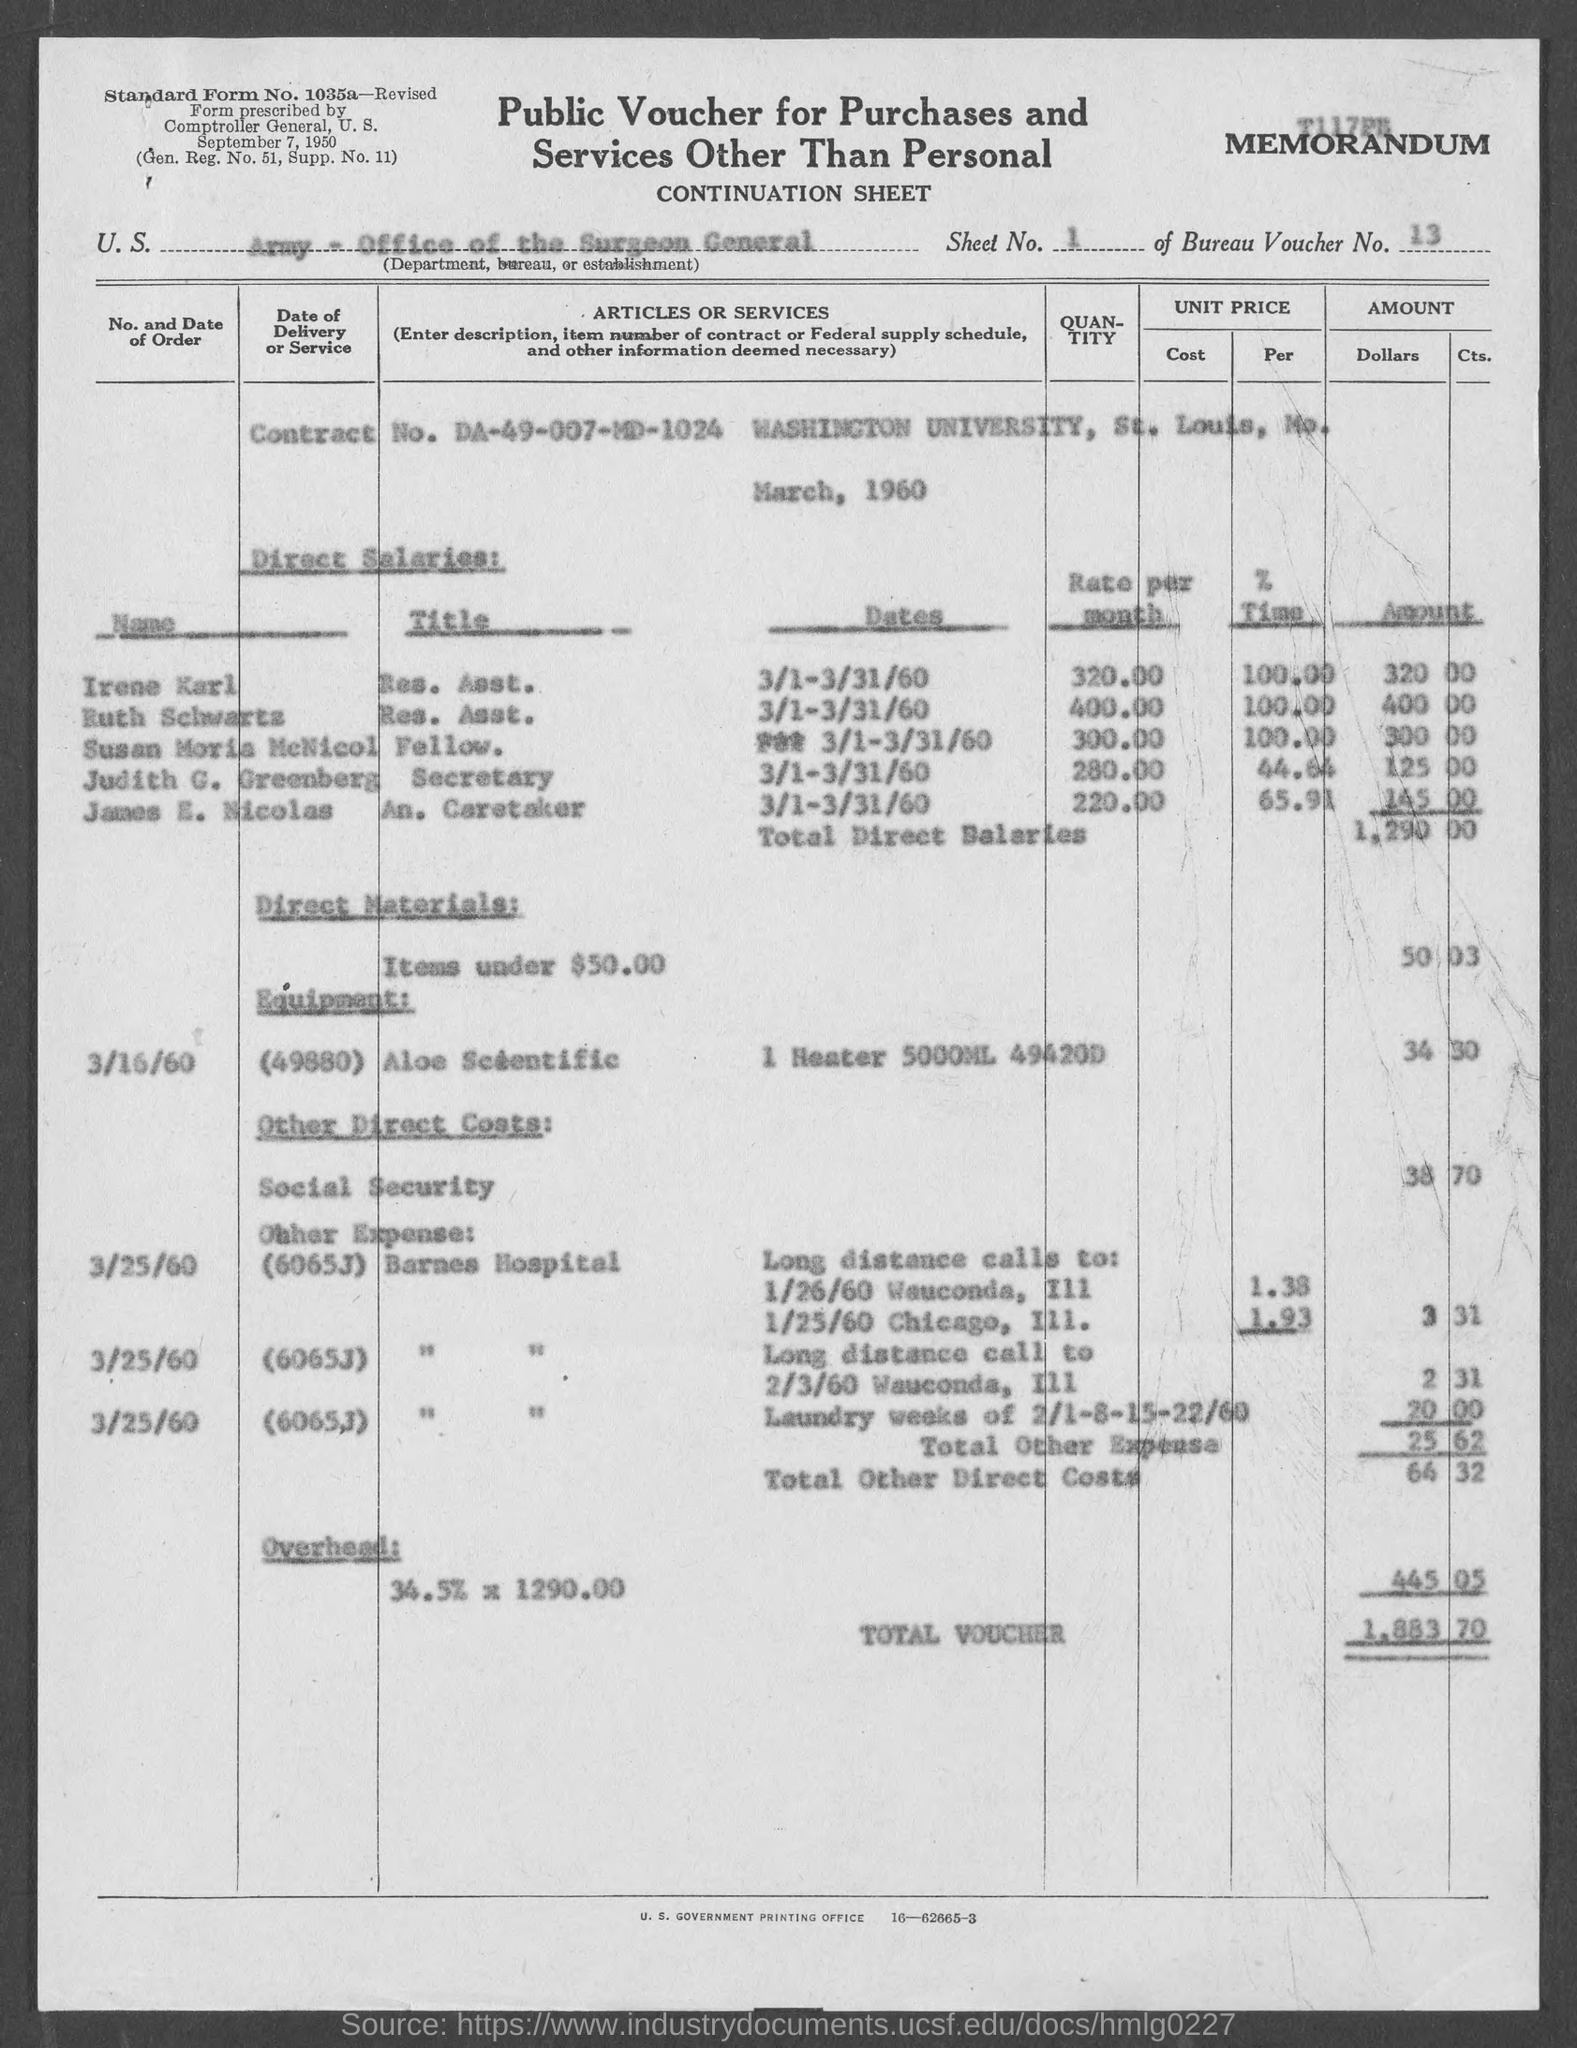What is the sheet no. mentioned in the given form ?
Your answer should be compact. 1. What is the bureau voucher no. mentioned in the given form ?
Provide a succinct answer. 13. What is the contract no. mentioned in the given form ?
Your answer should be very brief. DA-49-007-MD-1024. What is the amount for direct materials mentioned in the given form ?
Offer a very short reply. 50 03. What is the amount for total other direct costs mentioned in the given voucher ?
Provide a short and direct response. 64 32. What is the amount for the total voucher mentioned in the given form ?
Ensure brevity in your answer.  1,883 70. 